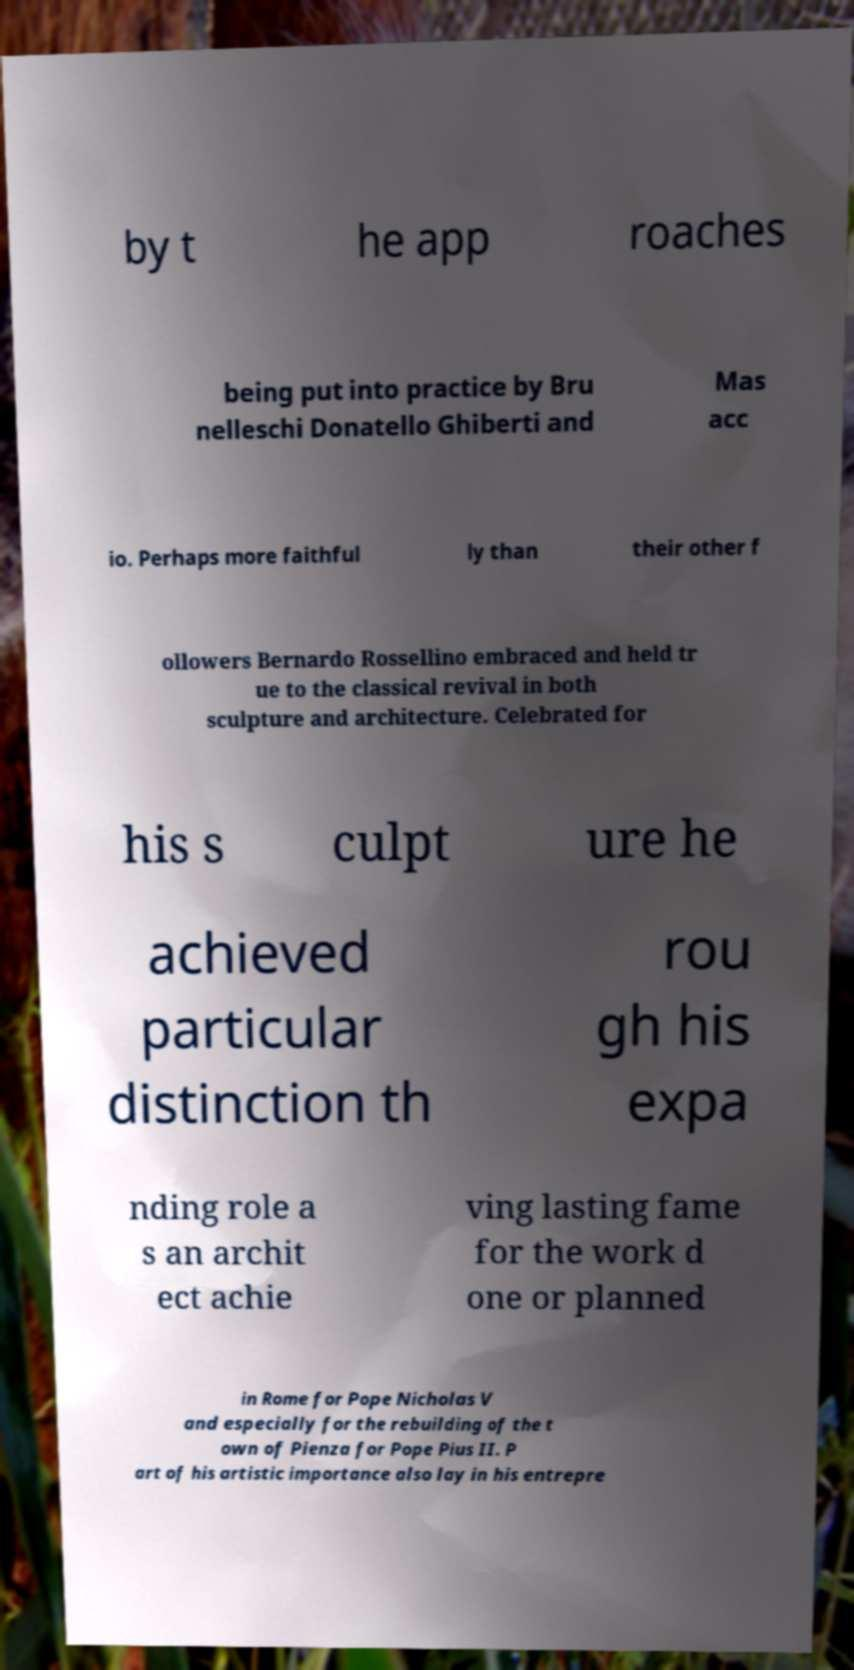Could you extract and type out the text from this image? by t he app roaches being put into practice by Bru nelleschi Donatello Ghiberti and Mas acc io. Perhaps more faithful ly than their other f ollowers Bernardo Rossellino embraced and held tr ue to the classical revival in both sculpture and architecture. Celebrated for his s culpt ure he achieved particular distinction th rou gh his expa nding role a s an archit ect achie ving lasting fame for the work d one or planned in Rome for Pope Nicholas V and especially for the rebuilding of the t own of Pienza for Pope Pius II. P art of his artistic importance also lay in his entrepre 